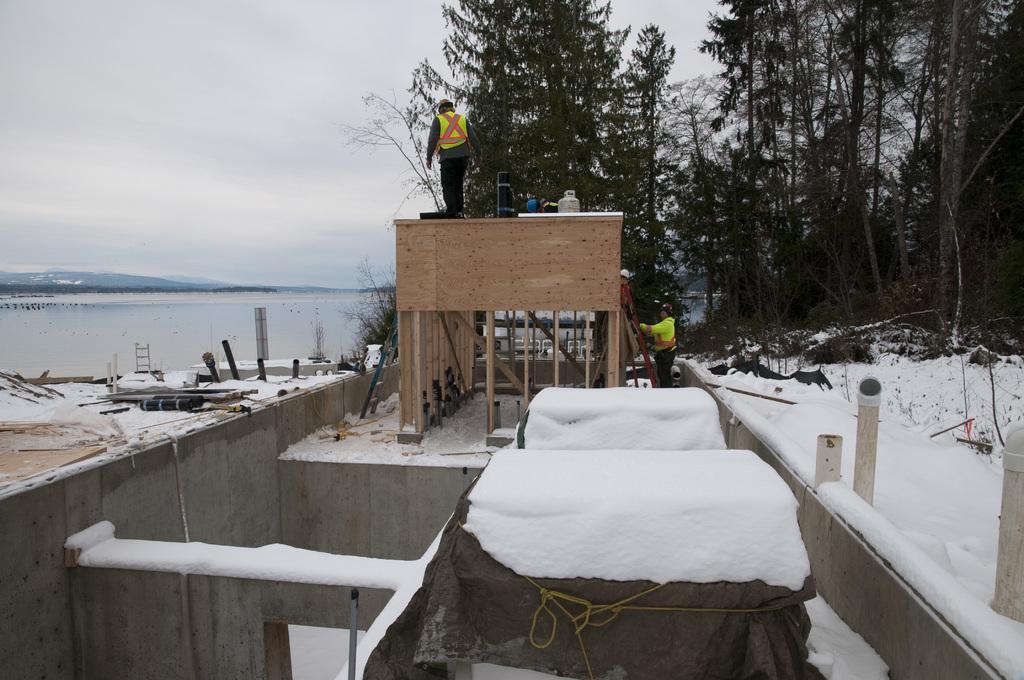Please provide a concise description of this image. In the foreground of the picture there is a construction going on and there are wooden planks, many machinery and there are people working. On the left there is a water body. On the right there are trees. In the background it is Sky. 